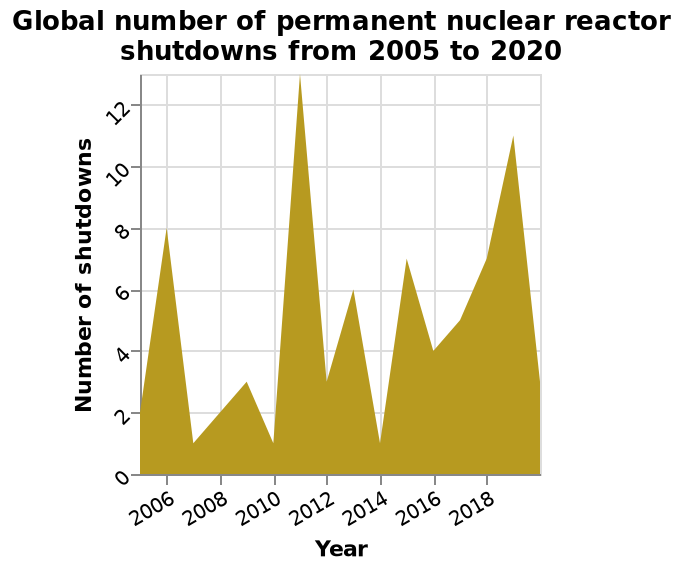<image>
please describe the details of the chart Here a area chart is titled Global number of permanent nuclear reactor shutdowns from 2005 to 2020. There is a linear scale of range 2006 to 2018 along the x-axis, marked Year. A linear scale of range 0 to 12 can be seen along the y-axis, labeled Number of shutdowns. What does the y-axis represent? The y-axis represents the number of shutdowns, ranging from 0 to 12. What is the title of the area chart?  The title of the area chart is "Global number of permanent nuclear reactor shutdowns from 2005 to 2020." What is the maximum value reached in the highest year?  12 How many years were closely following the highest year?  1 